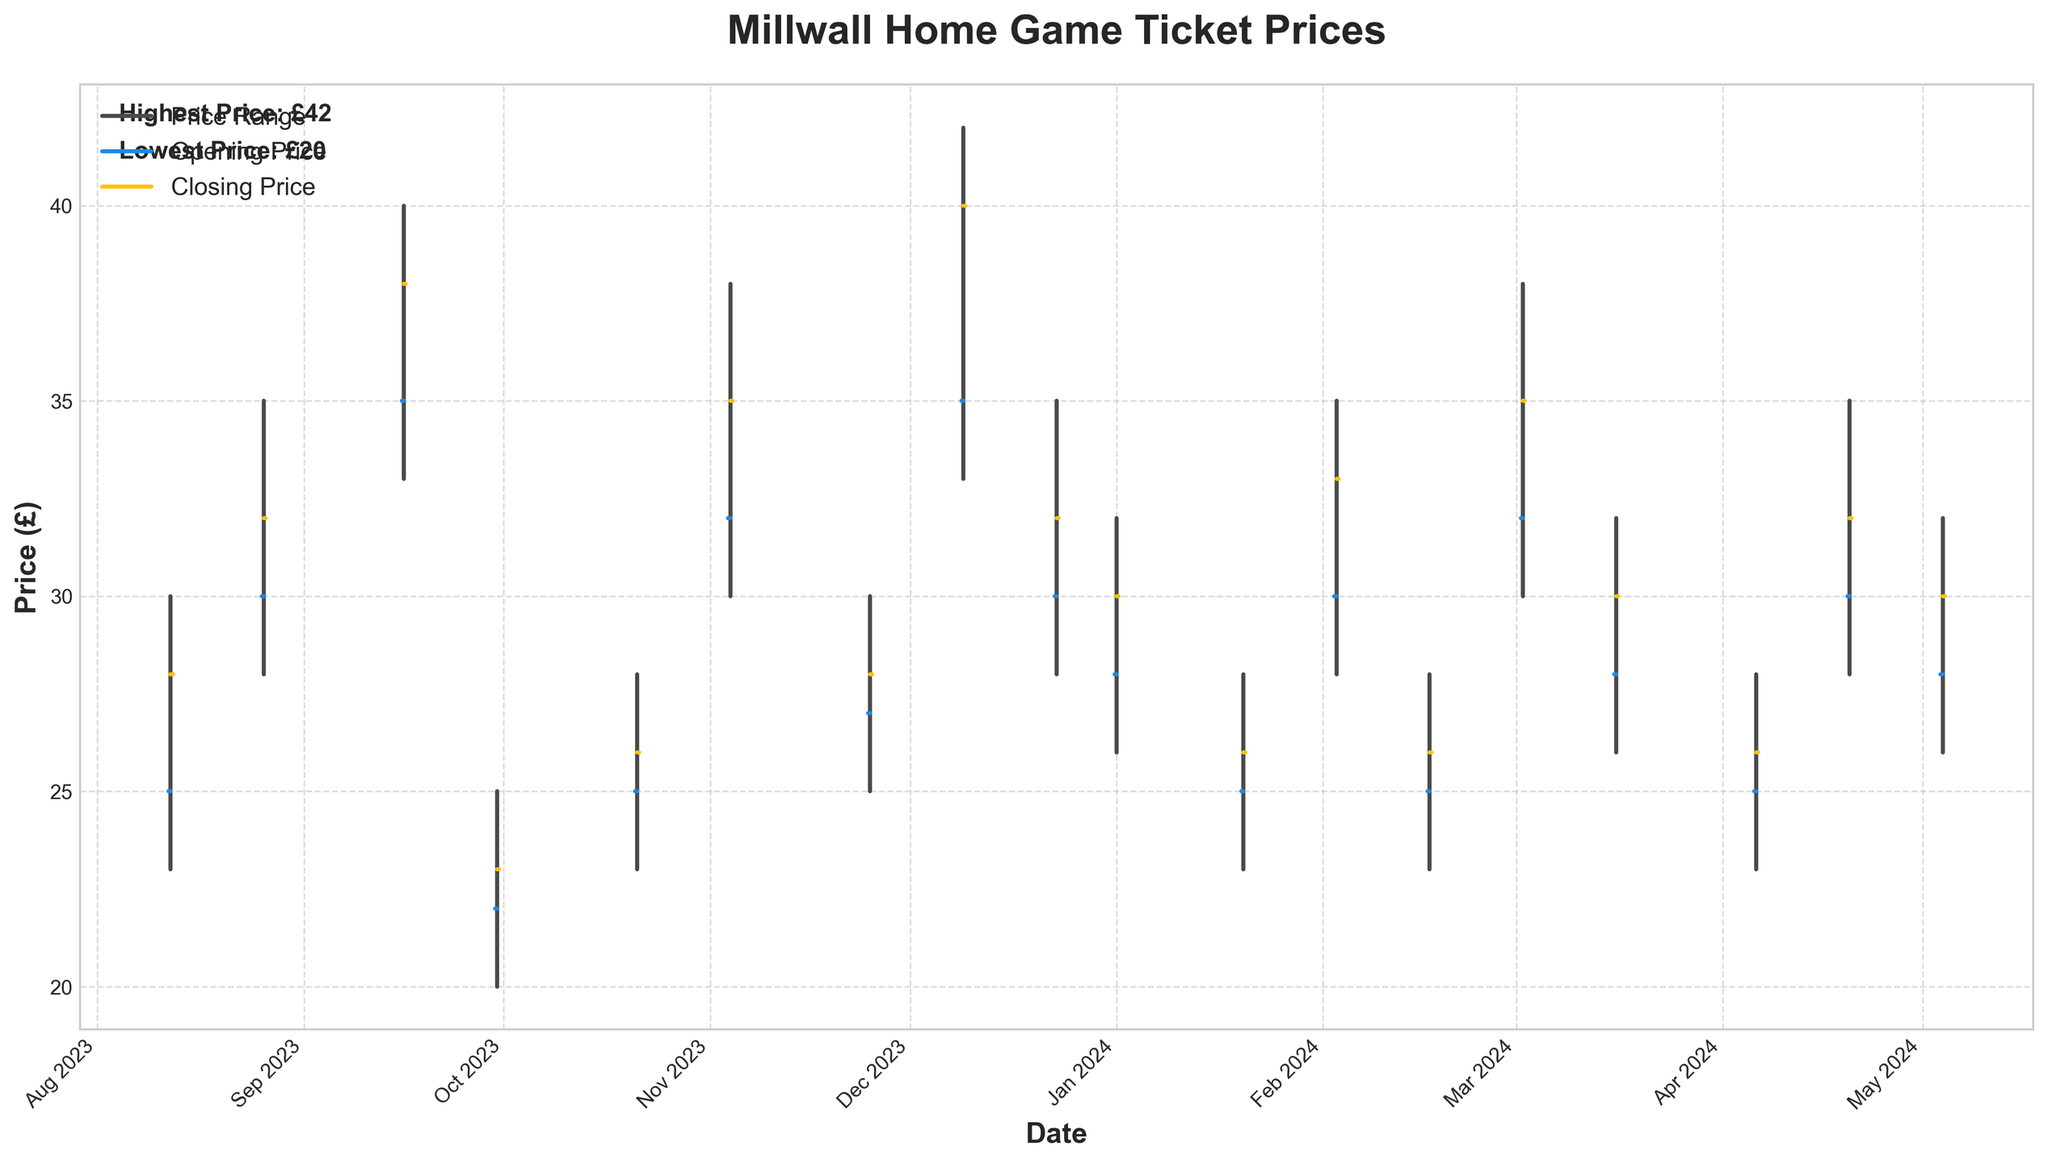What is the highest ticket price observed? The highest price can be seen in the chart where the top of the vertical line reaches its maximum point. This occurs for the game against Leicester City on December 9, 2023, with a high of £42.
Answer: £42 What is the closing price for the match against Blackburn Rovers? For the Blackburn Rovers game, the closing price can be found at the end of the horizontal yellow line on that date, which is October 21, 2023. The closing price is £26.
Answer: £26 Which game showed the greatest volatility in ticket prices? Volatility can be determined by the length of the vertical lines, representing the range from the lowest to the highest price. The longest line appears for the game against Leicester City on December 9, 2023, with a range from £33 to £42.
Answer: Leicester City How many games had a closing ticket price of £32? Identify the games where the horizontal yellow lines end at the £32 mark on the y-axis. These games are against Norwich City (August 26, 2023), Queens Park Rangers (December 23, 2023), and Middlesbrough (April 20, 2024).
Answer: 3 games What is the average opening price for the matches in December? Only two games are in December: against Leicester City (opening price £35) and Queens Park Rangers (opening price £30). The average is calculated as (35 + 30) / 2 = 32.5.
Answer: £32.5 What was the price range for the match against Plymouth Argyle? The price range for Plymouth Argyle is the difference between the high and low prices. The high was £30, and the low was £23, so the range is £30 - £23 = £7.
Answer: £7 Which match had the lowest opening price? The lowest opening price is observed at £22, which belongs to the match against Rotherham United on September 30, 2023.
Answer: Rotherham United Compare the closing prices of the matches against Southampton and Sunderland. Which one is higher? Find the closing prices for both matches. Southampton's closing price is £35, and Sunderland's closing price is also £35, so they are equal.
Answer: Both are equal at £35 What was the ticket price trend for the match against Leeds United? For Leeds United, on September 16, 2023, the price opened at £35, reached a high of £40, a low of £33, and closed at £38. The trend shows an overall increase from the opening to the close.
Answer: Increased How does the ticket price for the match against Sheffield Wednesday compare to the average closing price of all matches? First, calculate the average closing price for all matches, then compare it to the closing price for Sheffield Wednesday (£26 on February 17, 2024). The average closing price is (sum of all closing prices) / 18 games. The average is (£28 + £32 + £38 + £23 + £26 + £35 + £28 + £40 + £32 + £30 + £26 + £33 + £26 + £35 + £30 + £26 + £32 + £30) / 18 = £30. The Sheffield Wednesday game's closing price is lower than the overall average.
Answer: £26, which is lower than the average £30 